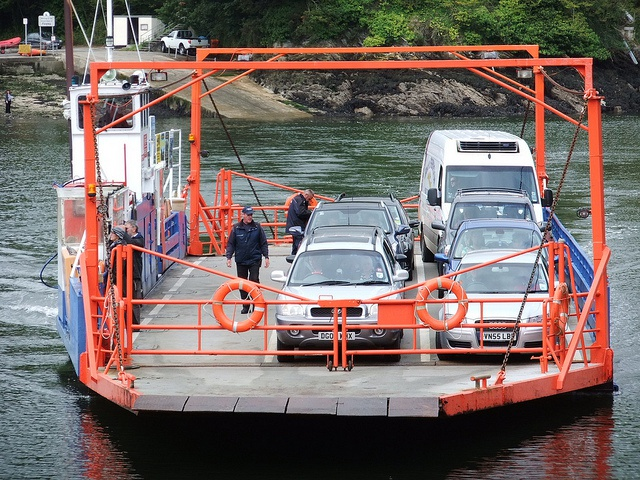Describe the objects in this image and their specific colors. I can see boat in black, darkgray, gray, and lightgray tones, car in black, white, and darkgray tones, car in black, white, darkgray, and salmon tones, truck in black, white, gray, and darkgray tones, and car in black, darkgray, gray, and lightgray tones in this image. 